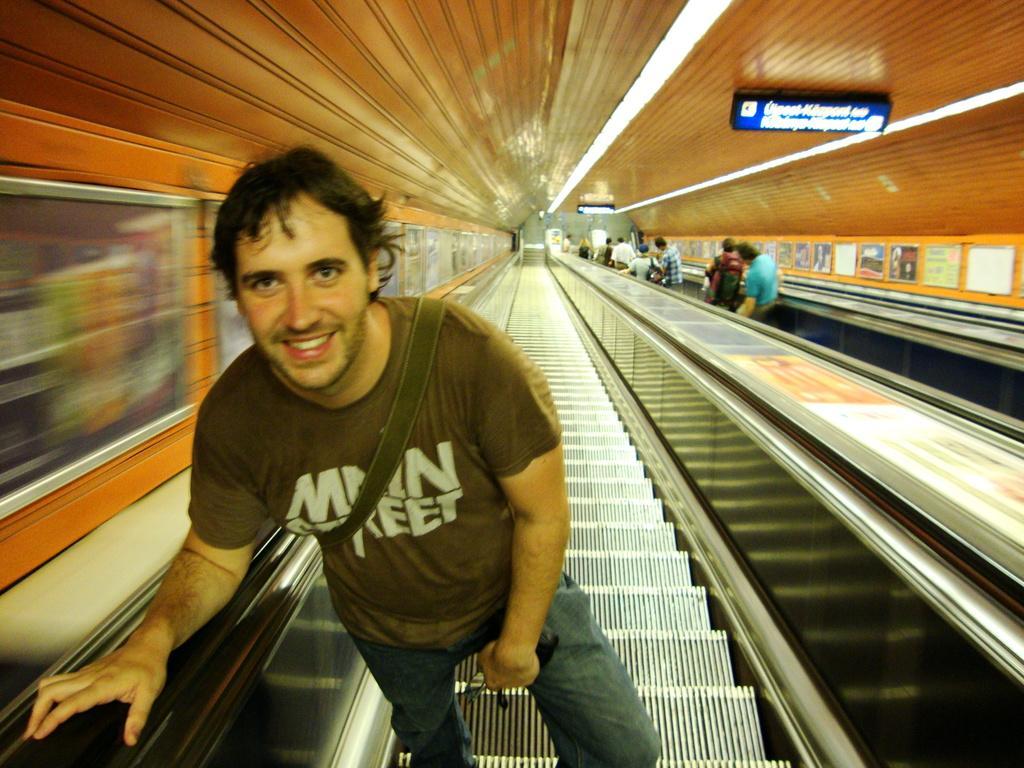Describe this image in one or two sentences. In this image we can see a person standing on an escalator. To the right side of the image there are people standing on an escalator. At the top of the image there is ceiling. To the both sides of the image there are walls with photo frames. There is a board with some text. 